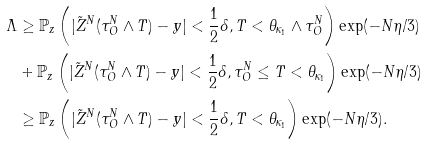Convert formula to latex. <formula><loc_0><loc_0><loc_500><loc_500>\Lambda & \geq \mathbb { P } _ { z } \left ( | \tilde { Z } ^ { N } ( \tau ^ { N } _ { O } \wedge T ) - y | < \frac { 1 } { 2 } \delta , T < \theta _ { \kappa _ { 1 } } \wedge \tau ^ { N } _ { O } \right ) \exp ( - N \eta / 3 ) \\ & + \mathbb { P } _ { z } \left ( | \tilde { Z } ^ { N } ( \tau ^ { N } _ { O } \wedge T ) - y | < \frac { 1 } { 2 } \delta , \tau ^ { N } _ { O } \leq T < \theta _ { \kappa _ { 1 } } \right ) \exp ( - N \eta / 3 ) \\ & \geq \mathbb { P } _ { z } \left ( | \tilde { Z } ^ { N } ( \tau ^ { N } _ { O } \wedge T ) - y | < \frac { 1 } { 2 } \delta , T < \theta _ { \kappa _ { 1 } } \right ) \exp ( - N \eta / 3 ) .</formula> 